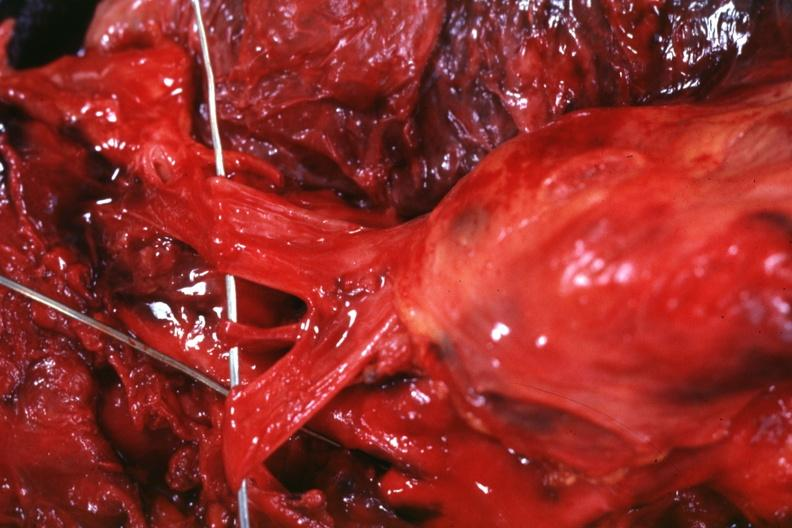what is the superior vena cava invaded by?
Answer the question using a single word or phrase. Invaded tumor 